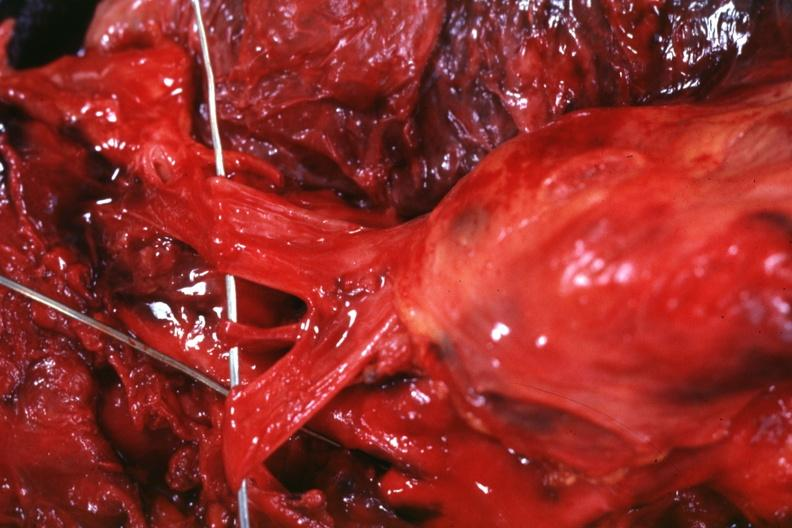what is the superior vena cava invaded by?
Answer the question using a single word or phrase. Invaded tumor 